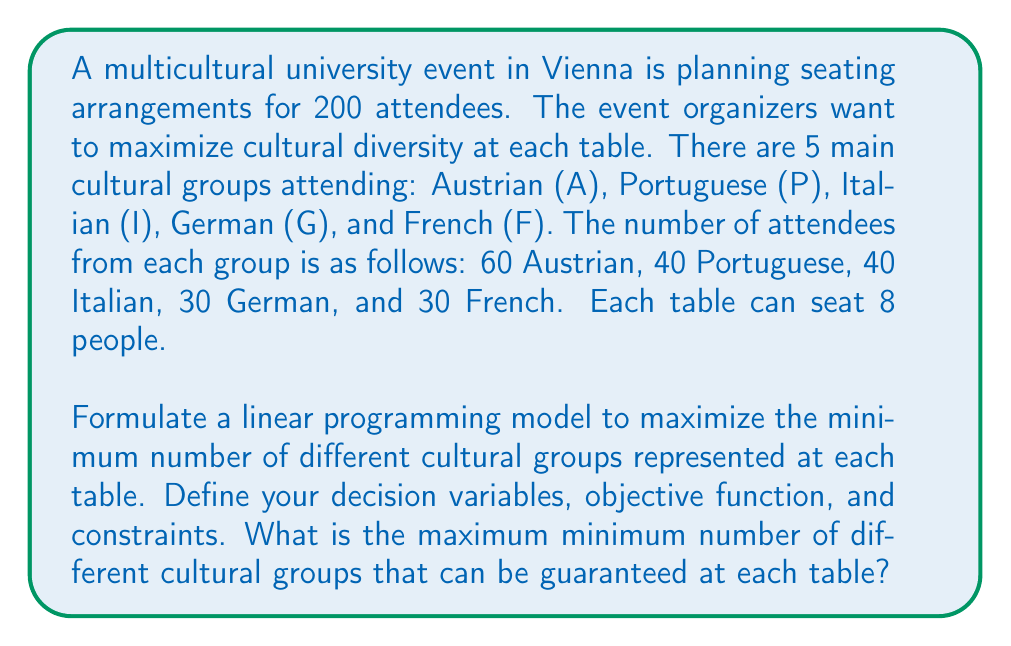Show me your answer to this math problem. Let's approach this step-by-step:

1) First, we need to define our decision variables:
   Let $x_{ijklm}$ be the number of tables with i Austrians, j Portuguese, k Italians, l Germans, and m French.

2) Our objective is to maximize the minimum number of different cultural groups at each table. We can introduce a variable y to represent this minimum and maximize y.

3) Constraints:
   a) The sum of people at all tables must equal the total number of attendees from each group:
      $$\sum_{i+j+k+l+m=8} ix_{ijklm} = 60$$ (Austrians)
      $$\sum_{i+j+k+l+m=8} jx_{ijklm} = 40$$ (Portuguese)
      $$\sum_{i+j+k+l+m=8} kx_{ijklm} = 40$$ (Italians)
      $$\sum_{i+j+k+l+m=8} lx_{ijklm} = 30$$ (Germans)
      $$\sum_{i+j+k+l+m=8} mx_{ijklm} = 30$$ (French)

   b) The total number of tables must be 25 (200 attendees ÷ 8 seats per table):
      $$\sum_{i+j+k+l+m=8} x_{ijklm} = 25$$

   c) For each table configuration, if any group is present (i.e., i, j, k, l, or m > 0), it contributes to the count of different groups. We want y to be less than or equal to this count for all configurations:
      $$y \leq (i>0) + (j>0) + (k>0) + (l>0) + (m>0)$$ for all $x_{ijklm} > 0$

   d) All variables must be non-negative integers:
      $$x_{ijklm}, y \in \mathbb{Z}^+$$

4) The objective function is simply:
   Maximize y

5) Solving this integer linear programming problem (which is quite complex due to the number of variables) would give us the optimal seating arrangement and the maximum minimum number of different cultural groups at each table.

Given the distribution of attendees and the constraint of 8 people per table, we can deduce that the maximum minimum number of different cultural groups at each table cannot exceed 5, as there are only 5 groups in total.
Answer: The maximum minimum number of different cultural groups that can be guaranteed at each table is 4. This can be achieved by ensuring that each table has at least one person from 4 different cultural groups, with the fifth seat being filled by a member of any group. While it's theoretically possible to have all 5 groups at some tables, it cannot be guaranteed for all tables given the constraints. 